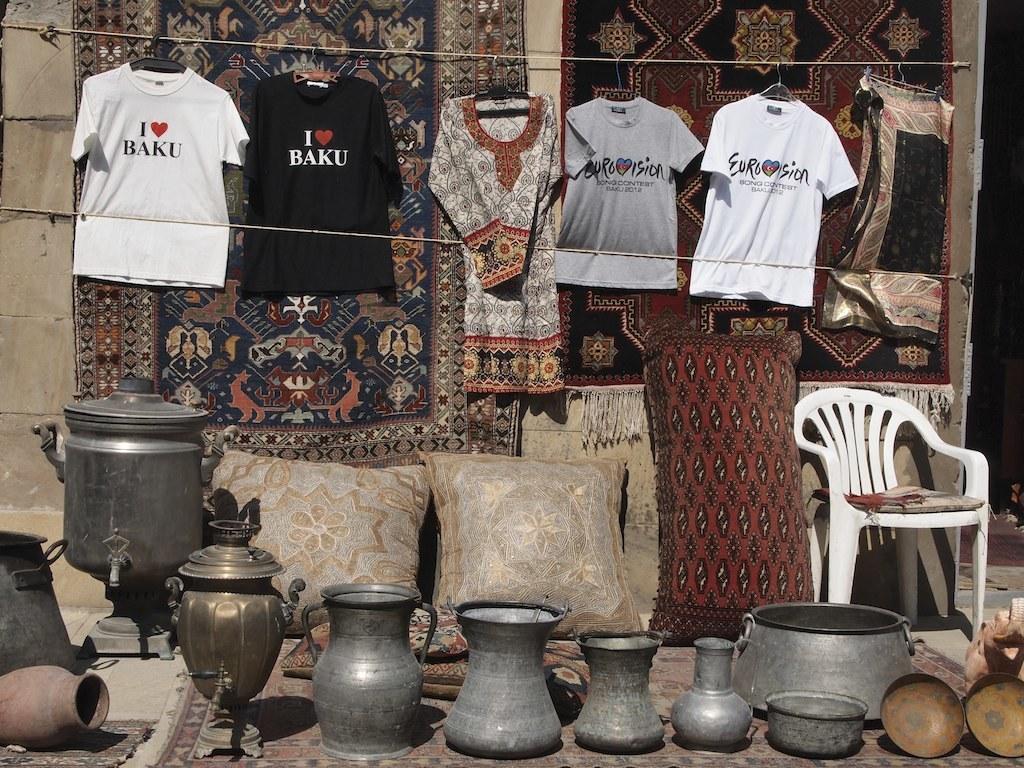What does the white shirt say?
Offer a very short reply. I love baku. 